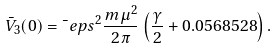Convert formula to latex. <formula><loc_0><loc_0><loc_500><loc_500>\bar { V } _ { 3 } ( 0 ) = \bar { \ } e p s ^ { 2 } \frac { m \mu ^ { 2 } } { 2 \pi } \left ( \frac { \gamma } { 2 } + 0 . 0 5 6 8 5 2 8 \right ) .</formula> 